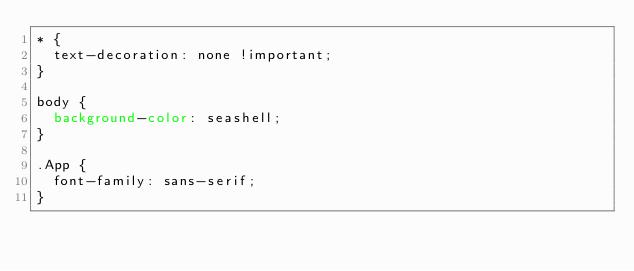Convert code to text. <code><loc_0><loc_0><loc_500><loc_500><_CSS_>* {
  text-decoration: none !important;
}

body {
  background-color: seashell;
}

.App {
  font-family: sans-serif;
}
</code> 